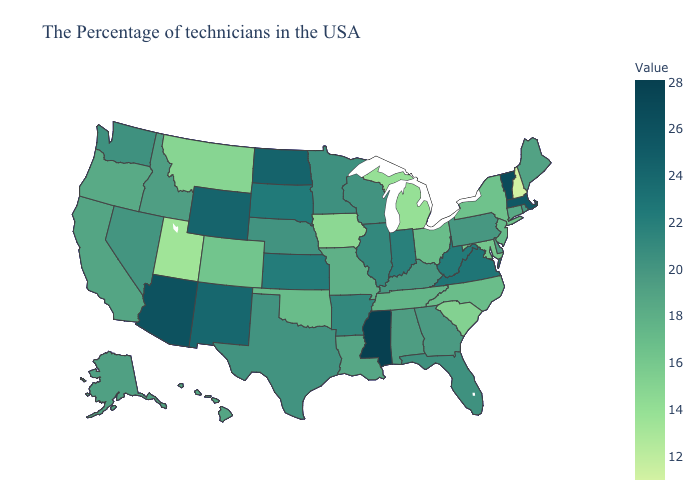Does Illinois have the highest value in the MidWest?
Short answer required. No. Does Alaska have the lowest value in the USA?
Quick response, please. No. Among the states that border Minnesota , which have the highest value?
Quick response, please. North Dakota. Which states have the lowest value in the USA?
Answer briefly. New Hampshire. Does Florida have a lower value than Tennessee?
Write a very short answer. No. Which states have the lowest value in the South?
Concise answer only. South Carolina. Does Maine have the lowest value in the USA?
Give a very brief answer. No. 